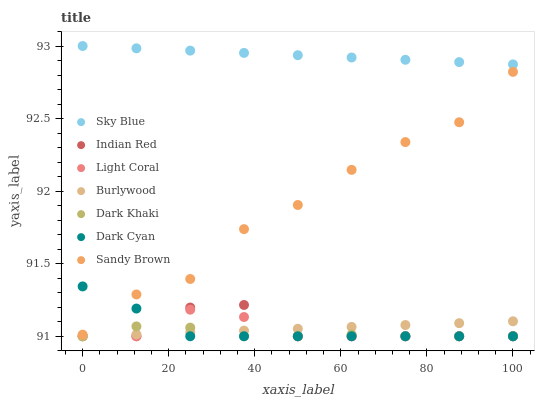Does Dark Khaki have the minimum area under the curve?
Answer yes or no. Yes. Does Sky Blue have the maximum area under the curve?
Answer yes or no. Yes. Does Burlywood have the minimum area under the curve?
Answer yes or no. No. Does Burlywood have the maximum area under the curve?
Answer yes or no. No. Is Burlywood the smoothest?
Answer yes or no. Yes. Is Sandy Brown the roughest?
Answer yes or no. Yes. Is Light Coral the smoothest?
Answer yes or no. No. Is Light Coral the roughest?
Answer yes or no. No. Does Dark Khaki have the lowest value?
Answer yes or no. Yes. Does Sky Blue have the lowest value?
Answer yes or no. No. Does Sky Blue have the highest value?
Answer yes or no. Yes. Does Burlywood have the highest value?
Answer yes or no. No. Is Indian Red less than Sandy Brown?
Answer yes or no. Yes. Is Sky Blue greater than Dark Khaki?
Answer yes or no. Yes. Does Light Coral intersect Burlywood?
Answer yes or no. Yes. Is Light Coral less than Burlywood?
Answer yes or no. No. Is Light Coral greater than Burlywood?
Answer yes or no. No. Does Indian Red intersect Sandy Brown?
Answer yes or no. No. 